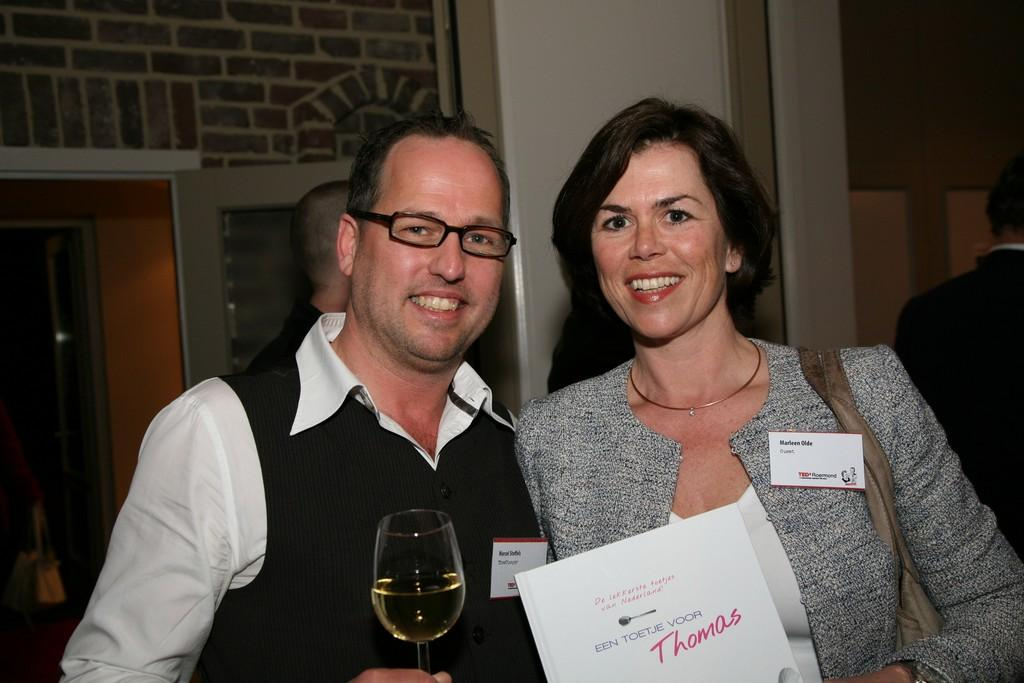<image>
Offer a succinct explanation of the picture presented. A woman and man both wearing name tags pose for a picture 